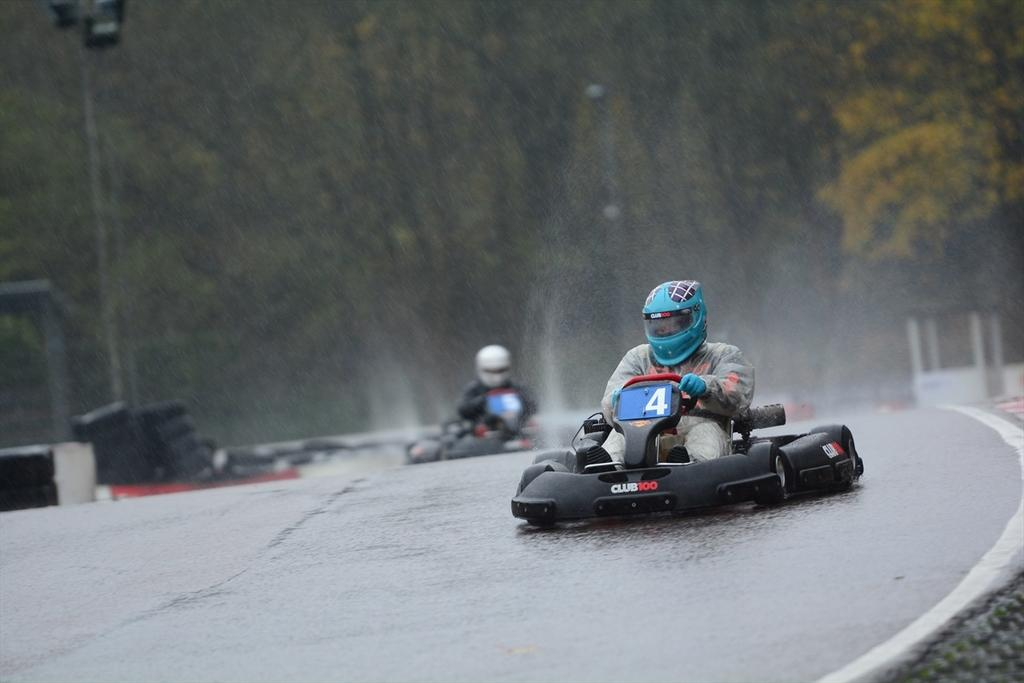How many people are in the image? There are two persons in the image. What are the persons wearing on their heads? The persons are wearing helmets. What are the persons doing in the image? The persons are riding vehicles. What can be seen in the background of the image? There are trees in the background of the image. What type of crate is being used as an ornament in the image? There is no crate or ornament present in the image. 